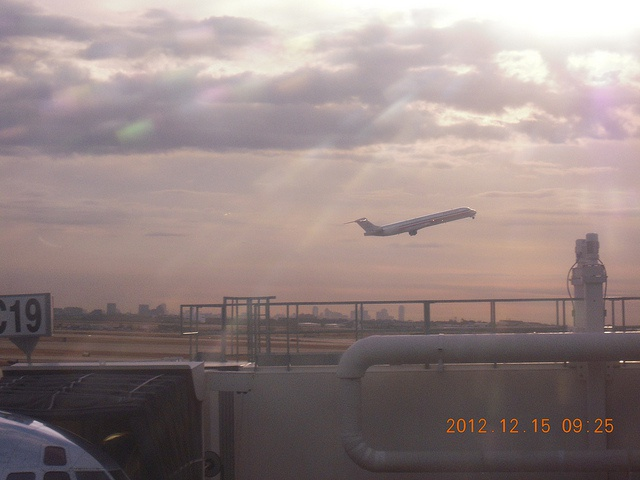Describe the objects in this image and their specific colors. I can see airplane in darkgray, gray, and black tones and airplane in darkgray and gray tones in this image. 